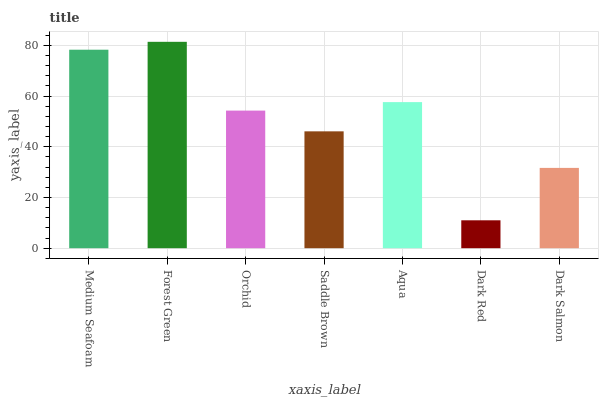Is Orchid the minimum?
Answer yes or no. No. Is Orchid the maximum?
Answer yes or no. No. Is Forest Green greater than Orchid?
Answer yes or no. Yes. Is Orchid less than Forest Green?
Answer yes or no. Yes. Is Orchid greater than Forest Green?
Answer yes or no. No. Is Forest Green less than Orchid?
Answer yes or no. No. Is Orchid the high median?
Answer yes or no. Yes. Is Orchid the low median?
Answer yes or no. Yes. Is Saddle Brown the high median?
Answer yes or no. No. Is Aqua the low median?
Answer yes or no. No. 